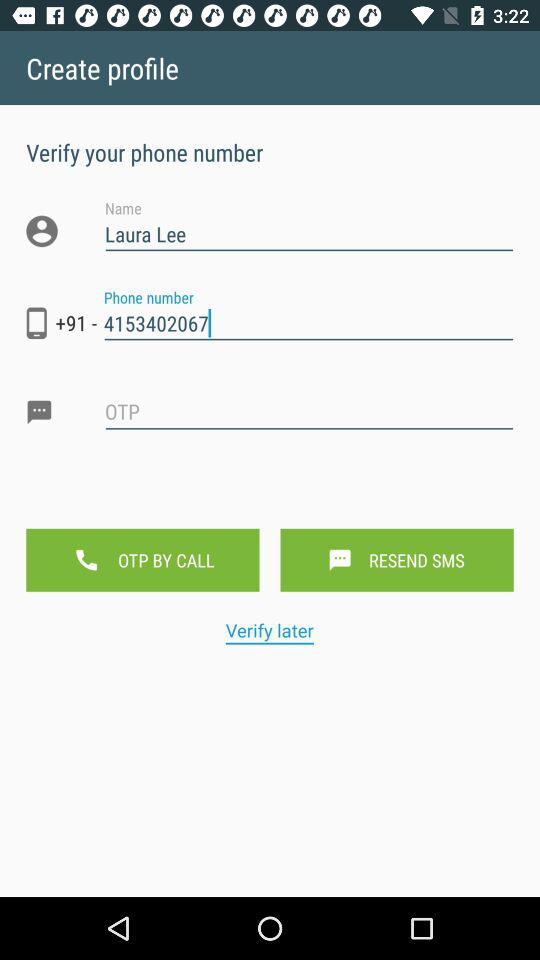What is the user name? The user name is Laura Lee. 